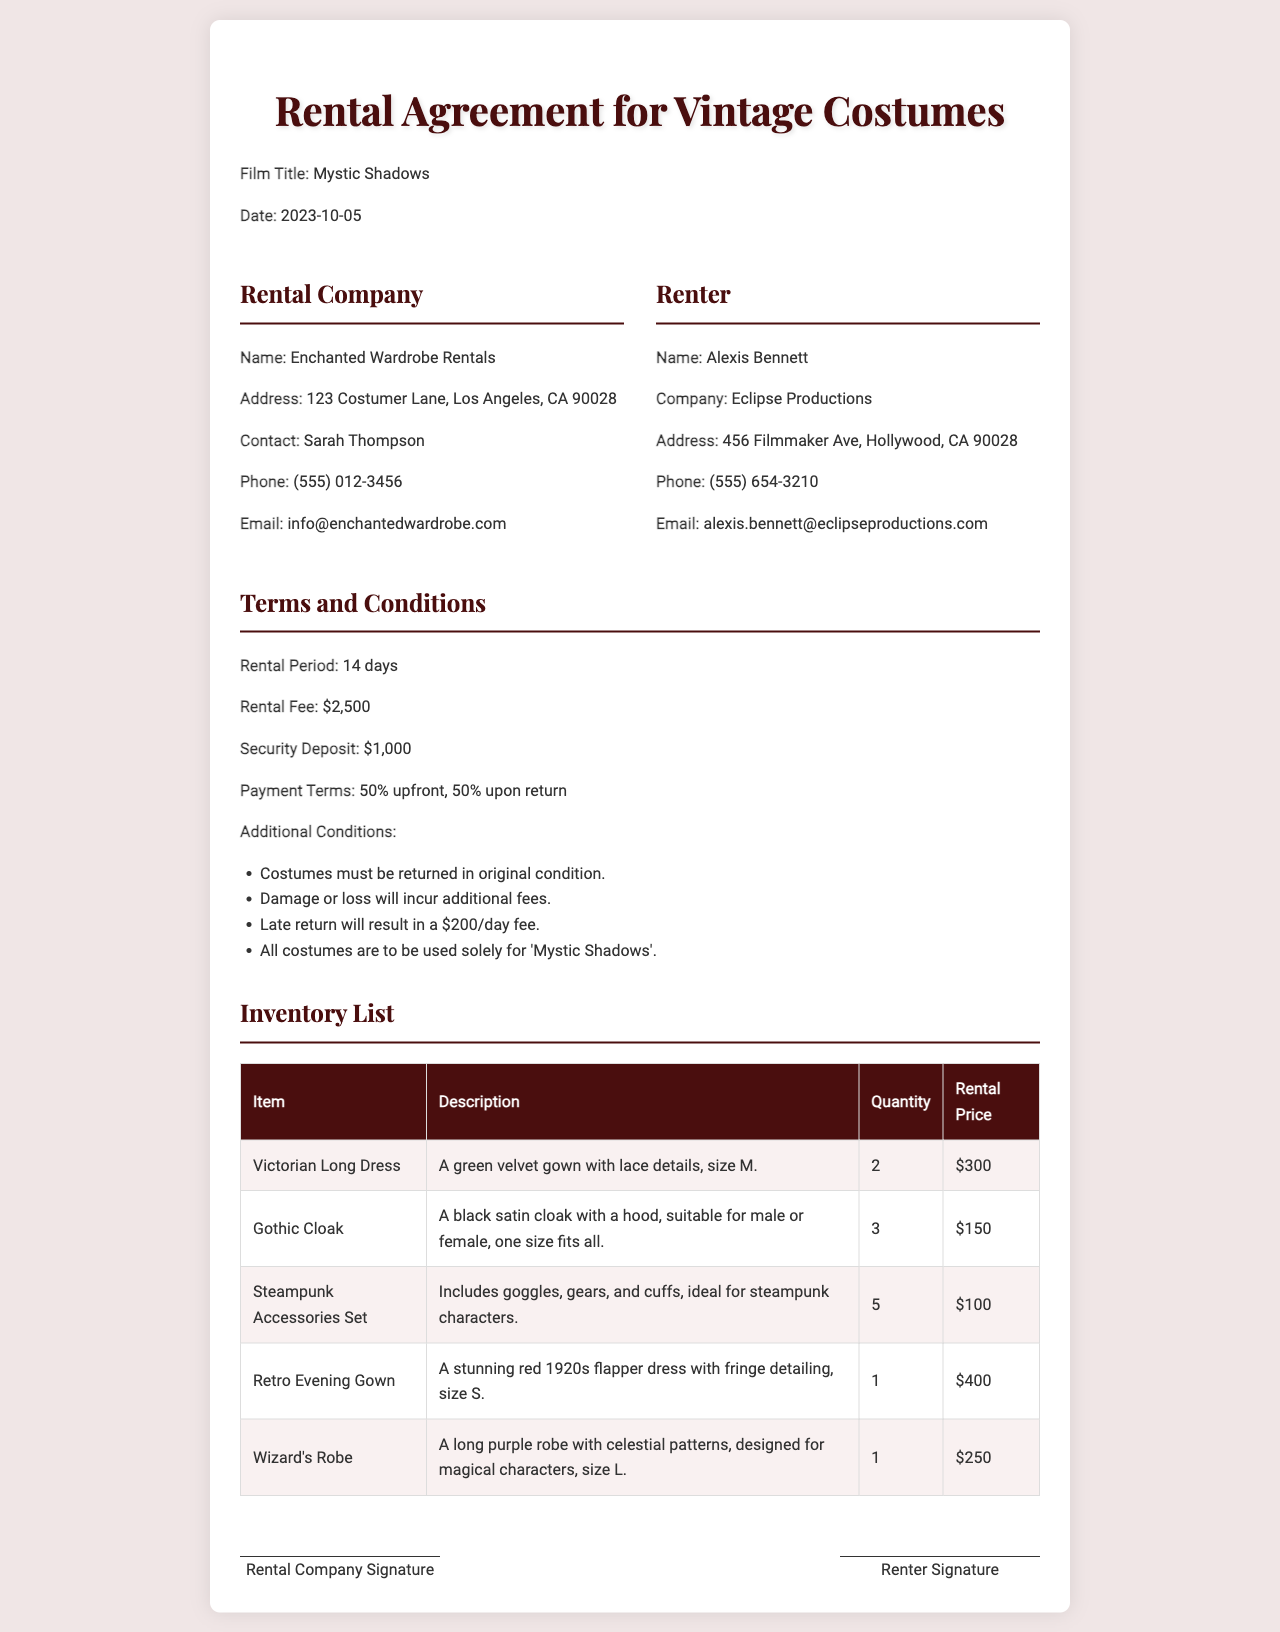what is the film title? The film title is explicitly stated in the document, which is "Mystic Shadows."
Answer: Mystic Shadows who is the renter's contact person? The renter's contact person is mentioned in the document as "Alexis Bennett."
Answer: Alexis Bennett what is the rental fee? The rental fee is listed in the terms and conditions section of the document, specifically denoting how much is to be paid for the rental.
Answer: $2,500 how many Victorian Long Dresses are available? The inventory list shows the quantity of Victorian Long Dresses available for rental, as specified in the document.
Answer: 2 what is the security deposit amount? The security deposit amount is indicated in the terms and conditions section of the document.
Answer: $1,000 how long is the rental period? The rental period is stated in the document, detailing how long the costumes can be rented.
Answer: 14 days what would happen if costumes are returned late? The terms mention consequences for late returns, specifying what fees will apply if costumes are not returned on time.
Answer: $200/day how many items are listed in the inventory? The total number of items listed in the inventory can be derived from counting the items in the inventory table in the document.
Answer: 5 what is the description of the Wizard's Robe? The document provides a detailed description of the Wizard's Robe that indicates its features and intended use.
Answer: A long purple robe with celestial patterns, designed for magical characters, size L 